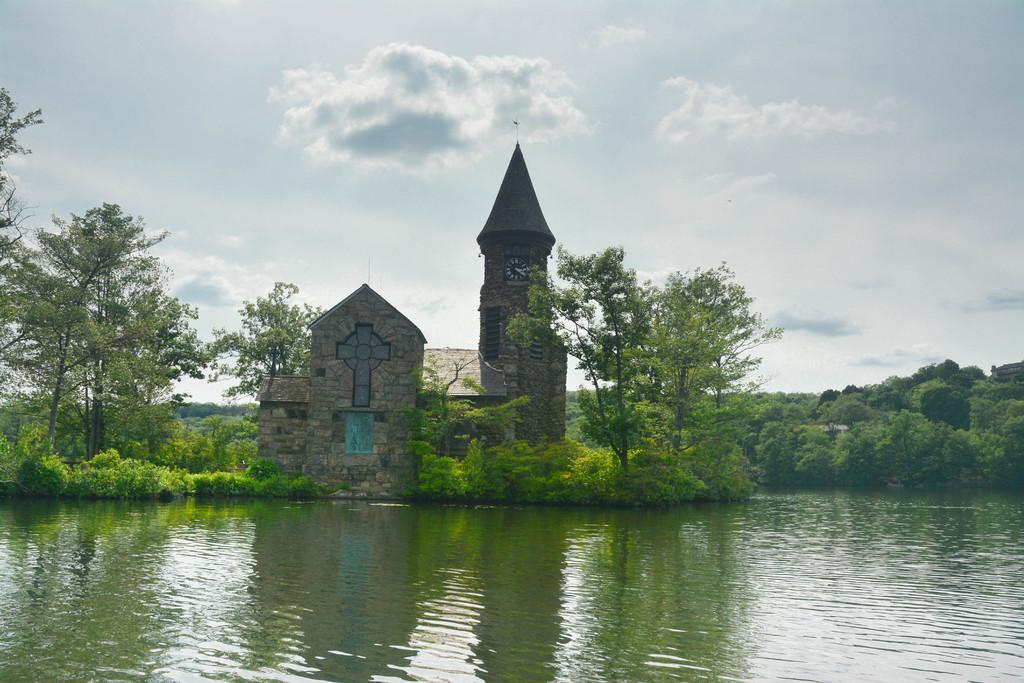Could you give a brief overview of what you see in this image? In this picture there is a building and there is a clock on the wall and there are trees. At the top there is sky and there are clouds. At the bottom there is water and there is a reflection of a building and there is a reflection of trees and there is a reflection of sky on the water. 